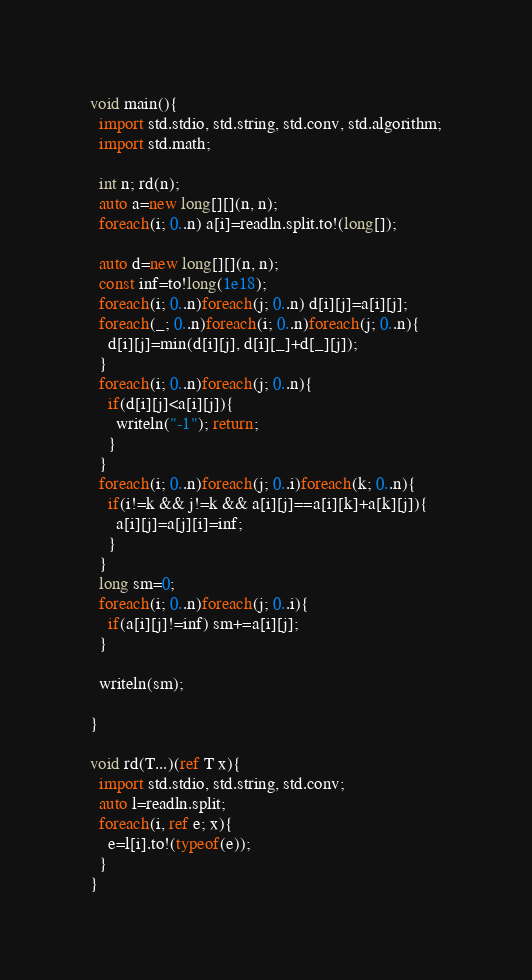<code> <loc_0><loc_0><loc_500><loc_500><_D_>void main(){
  import std.stdio, std.string, std.conv, std.algorithm;
  import std.math;
  
  int n; rd(n);
  auto a=new long[][](n, n);
  foreach(i; 0..n) a[i]=readln.split.to!(long[]);

  auto d=new long[][](n, n);
  const inf=to!long(1e18);
  foreach(i; 0..n)foreach(j; 0..n) d[i][j]=a[i][j];
  foreach(_; 0..n)foreach(i; 0..n)foreach(j; 0..n){
    d[i][j]=min(d[i][j], d[i][_]+d[_][j]);
  }
  foreach(i; 0..n)foreach(j; 0..n){
    if(d[i][j]<a[i][j]){
      writeln("-1"); return;
    }
  }
  foreach(i; 0..n)foreach(j; 0..i)foreach(k; 0..n){
    if(i!=k && j!=k && a[i][j]==a[i][k]+a[k][j]){
      a[i][j]=a[j][i]=inf;
    }
  }
  long sm=0;
  foreach(i; 0..n)foreach(j; 0..i){
    if(a[i][j]!=inf) sm+=a[i][j];
  }

  writeln(sm);

}

void rd(T...)(ref T x){
  import std.stdio, std.string, std.conv;
  auto l=readln.split;
  foreach(i, ref e; x){
    e=l[i].to!(typeof(e));
  }
}</code> 